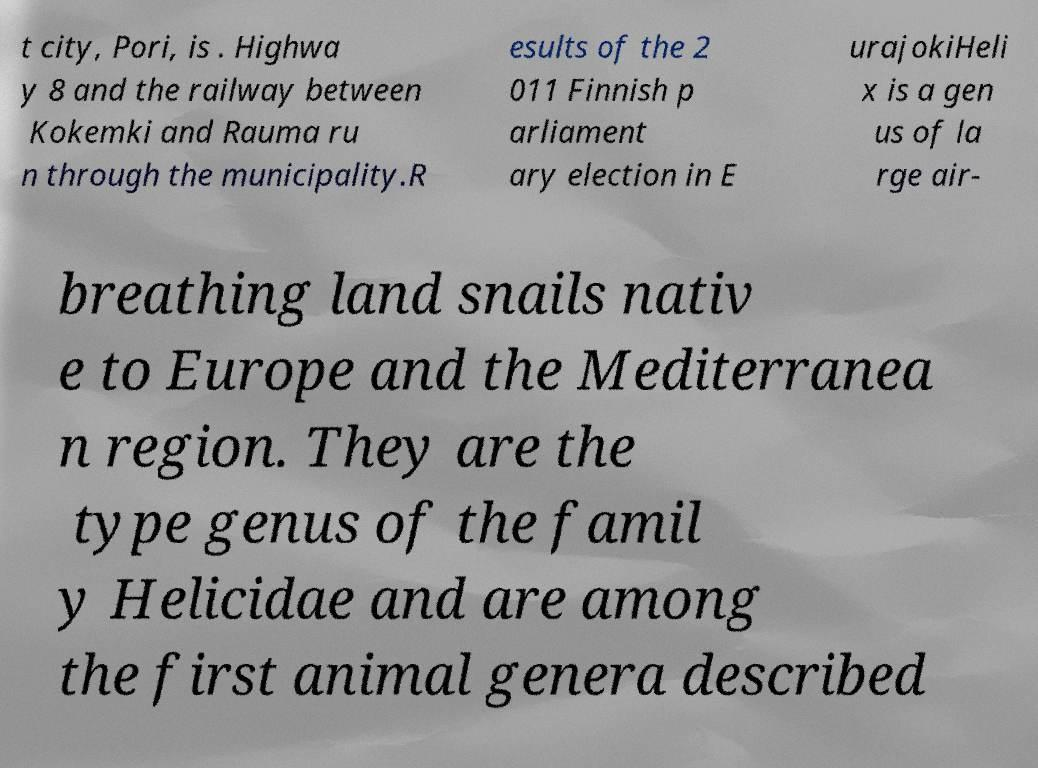Can you read and provide the text displayed in the image?This photo seems to have some interesting text. Can you extract and type it out for me? t city, Pori, is . Highwa y 8 and the railway between Kokemki and Rauma ru n through the municipality.R esults of the 2 011 Finnish p arliament ary election in E urajokiHeli x is a gen us of la rge air- breathing land snails nativ e to Europe and the Mediterranea n region. They are the type genus of the famil y Helicidae and are among the first animal genera described 